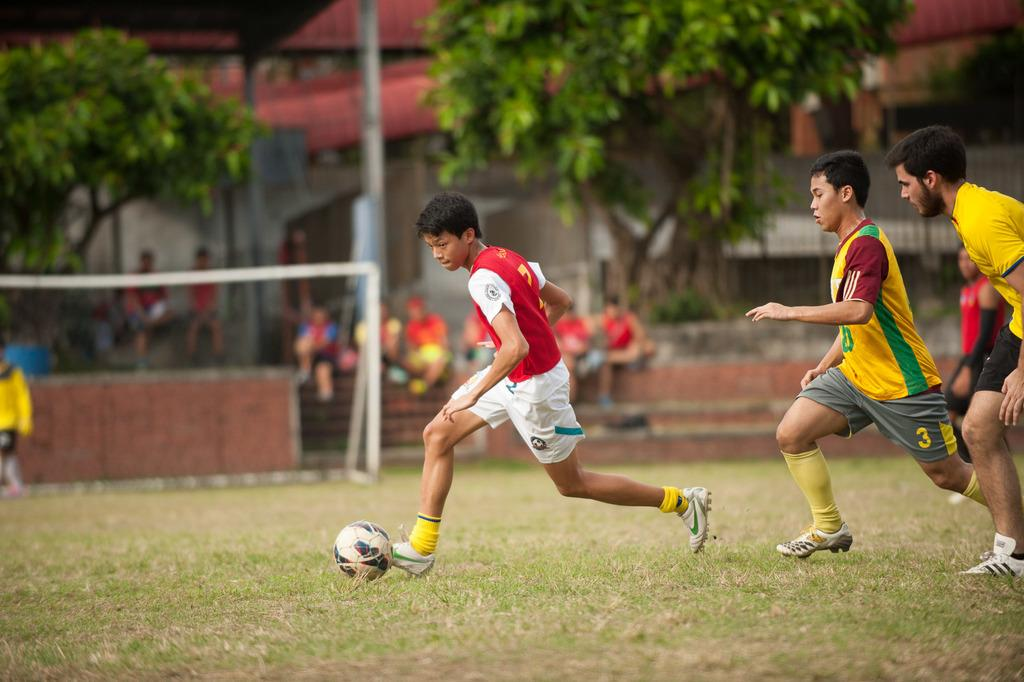<image>
Describe the image concisely. One of the soccer players has 3 written on his shorts. 